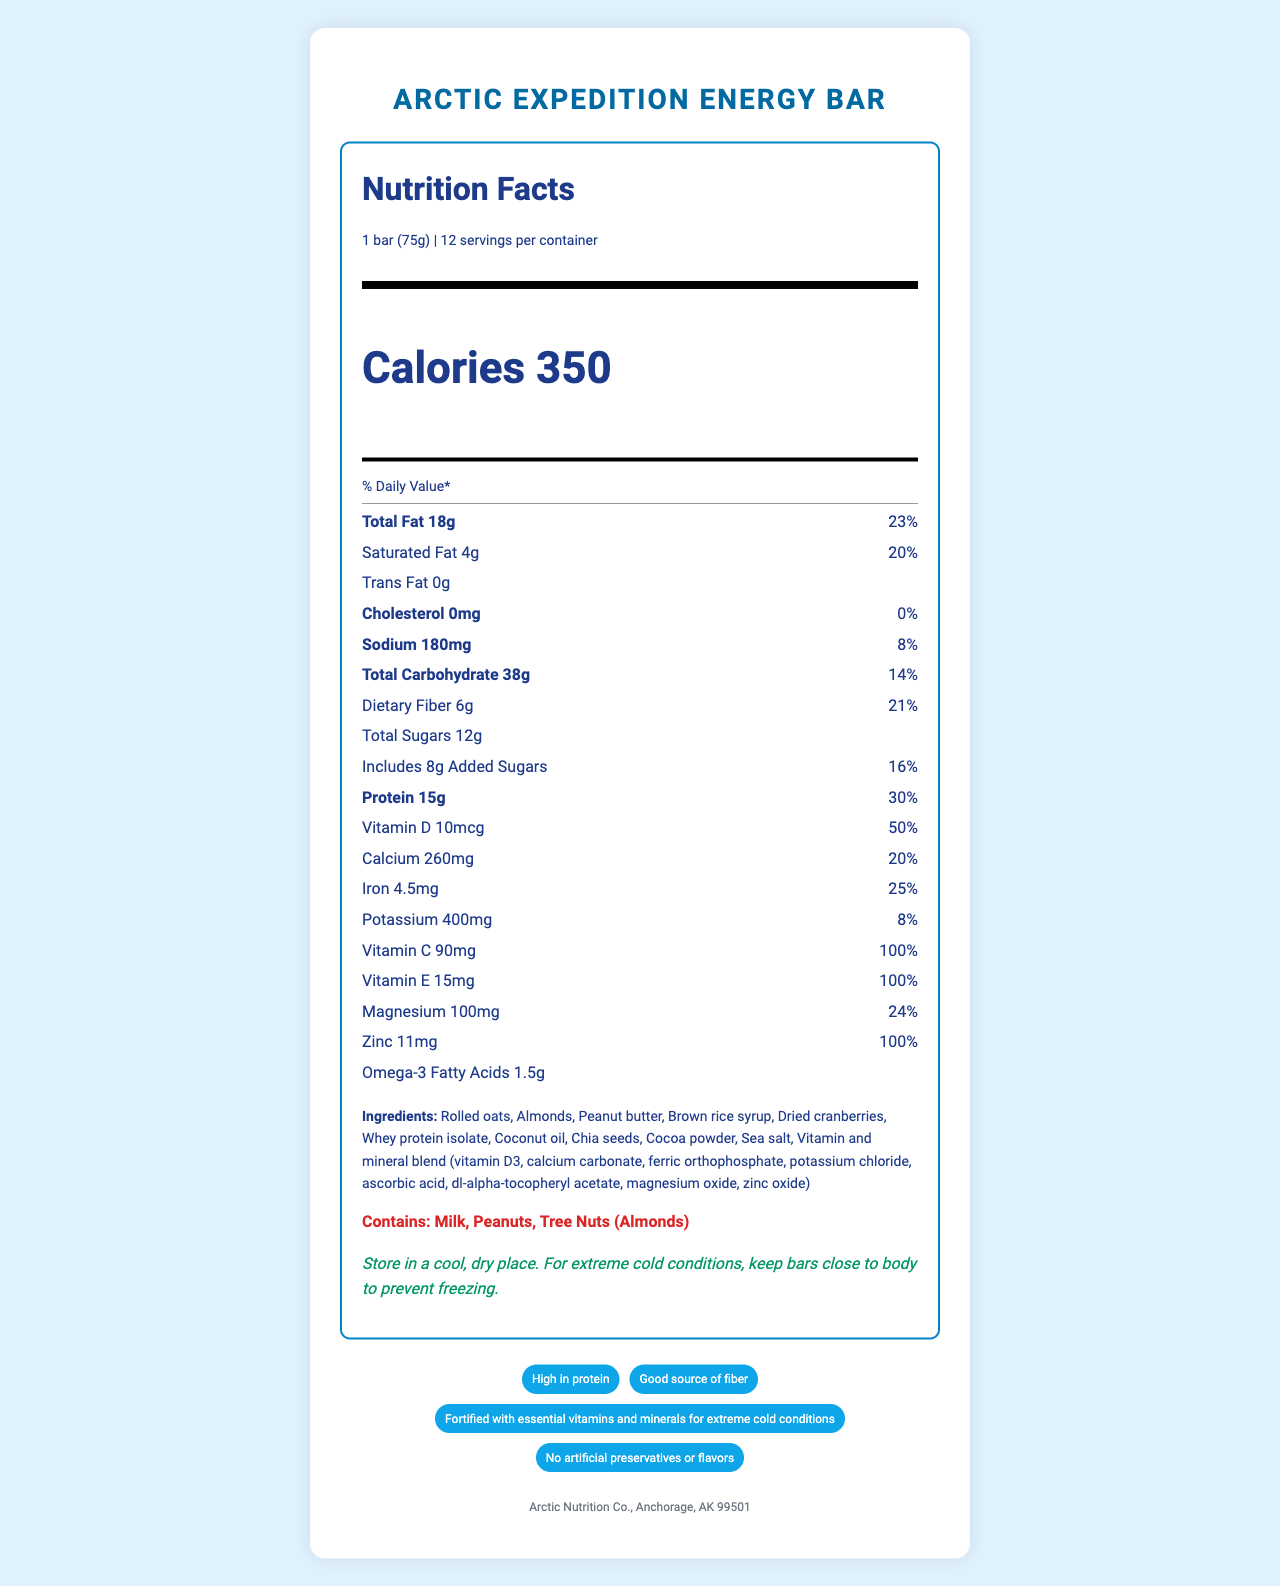what is the serving size of the Arctic Expedition Energy Bar? The serving size is specified as "1 bar (75g)" in the Nutrition Facts section.
Answer: 1 bar (75g) how many calories are there per serving of the energy bar? The document indicates that there are 350 calories per serving of the energy bar.
Answer: 350 what is the amount of total carbohydrates per serving? The amount of total carbohydrates per serving is listed as "38g" in the nutrient breakdown.
Answer: 38g is there any cholesterol in the Arctic Expedition Energy Bar? The document states that the cholesterol amount is "0mg" which means there is no cholesterol in the energy bar.
Answer: No what are the primary ingredients of the energy bar? The ingredients are listed under the "Ingredients" section in the document.
Answer: Rolled oats, Almonds, Peanut butter, Brown rice syrup, Dried cranberries, Whey protein isolate, Coconut oil, Chia seeds, Cocoa powder, Sea salt, Vitamin and mineral blend how much protein does one serving of the energy bar provide? A. 10g B. 12g C. 15g D. 20g The protein content per serving is listed as "15g" in the nutrient breakdown.
Answer: C. 15g what percentage of the daily value of Vitamin E does the energy bar provide? A. 50% B. 75% C. 100% D. 150% The document specifies that the energy bar provides 100% of the daily value of Vitamin E per serving.
Answer: C. 100% does the energy bar contain any added sugars? The document lists "Includes 8g Added Sugars" under the Total Sugars section.
Answer: Yes does the energy bar contain tree nuts? The allergen information mentions that the energy bar contains tree nuts (Almonds).
Answer: Yes where is the Arctic Expedition Energy Bar manufactured? The manufacturer information is provided at the bottom of the document.
Answer: Arctic Nutrition Co., Anchorage, AK 99501 describe the main nutritional benefits of the Arctic Expedition Energy Bar. The energy bar's nutritional label highlights its high protein content, essential vitamins, and minerals that cater to extreme cold conditions. Its claims of "High in protein," "Good source of fiber," and "Fortified with essential vitamins and minerals" emphasize its benefits.
Answer: The Arctic Expedition Energy Bar is high in protein (15g per serving), provides significant amounts of essential vitamins and minerals, including 100% of the daily value for Vitamin C, Vitamin E, and Zinc, and offers a good source of dietary fiber (6g per serving). It is designed to support energy and nutrition requirements in extreme cold conditions. what is the ratio of dietary fiber to total carbohydrate in the energy bar? The energy bar has 6g of dietary fiber and 38g of total carbohydrates. The ratio is 6g to 38g, or approximately 1:6.33.
Answer: Approximately 1:6.33 how many servings are there in one container of the energy bar? The document states that there are 12 servings per container.
Answer: 12 which of the following vitamins is present in the highest daily value percentage in one serving of the Arctic Expedition Energy Bar? A. Vitamin D B. Calcium C. Vitamin C D. Potassium The document shows that Vitamin C has a daily value percentage of 100%, which is higher compared to Vitamin D (50%), Calcium (20%), and Potassium (8%).
Answer: C. Vitamin C are artificial preservatives or flavors used in the energy bar? The document specifies that the energy bar contains "No artificial preservatives or flavors" as one of its claims and certifications.
Answer: No how should the energy bar be stored in extreme cold conditions? The storage instructions note to keep the bars close to the body in extreme cold conditions to prevent freezing.
Answer: Keep bars close to the body to prevent freezing what are the omega-3 fatty acids content per serving in the energy bar? The document lists Omega-3 Fatty Acids content as "1.5g" per serving.
Answer: 1.5g can you find information about the distribution channels for the Arctic Expedition Energy Bar in the document? The document does not provide details about the distribution channels for the energy bar.
Answer: Not enough information 